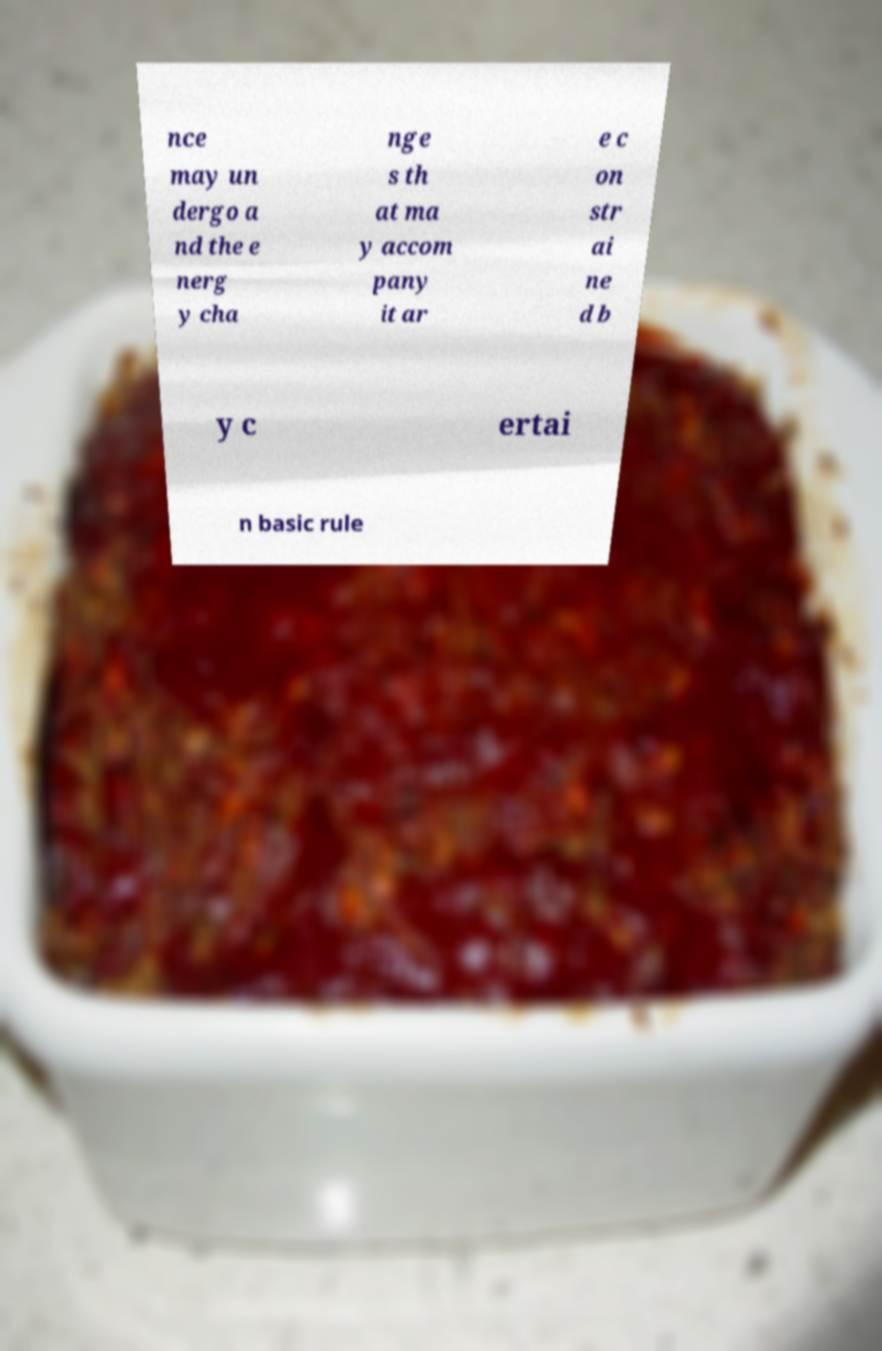I need the written content from this picture converted into text. Can you do that? nce may un dergo a nd the e nerg y cha nge s th at ma y accom pany it ar e c on str ai ne d b y c ertai n basic rule 